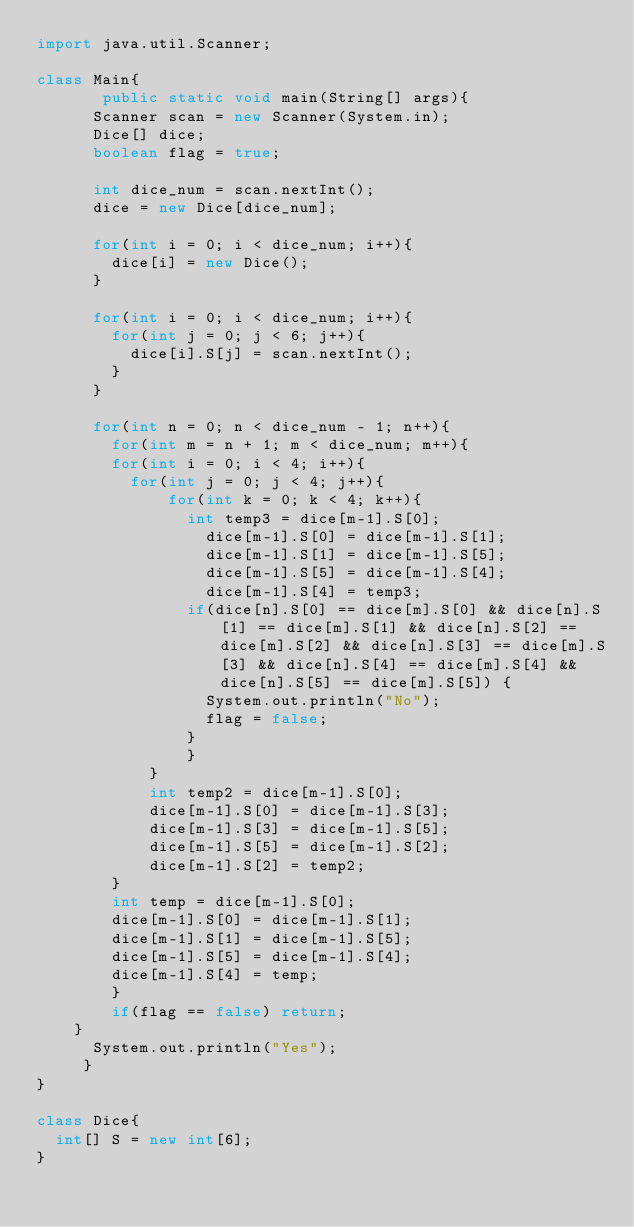<code> <loc_0><loc_0><loc_500><loc_500><_Java_>import java.util.Scanner;

class Main{
       public static void main(String[] args){
    	Scanner scan = new Scanner(System.in);
    	Dice[] dice;
    	boolean flag = true;
    	
    	int dice_num = scan.nextInt();
    	dice = new Dice[dice_num];
    	
    	for(int i = 0; i < dice_num; i++){
    		dice[i] = new Dice();
    	}
    	
    	for(int i = 0; i < dice_num; i++){
    		for(int j = 0; j < 6; j++){
    			dice[i].S[j] = scan.nextInt();
    		}
    	}
    	
    	for(int n = 0; n < dice_num - 1; n++){
    		for(int m = n + 1; m < dice_num; m++){
				for(int i = 0; i < 4; i++){
					for(int j = 0; j < 4; j++){
			    		for(int k = 0; k < 4; k++){
			    			int temp3 = dice[m-1].S[0];
			        		dice[m-1].S[0] = dice[m-1].S[1];
			        		dice[m-1].S[1] = dice[m-1].S[5];
			        		dice[m-1].S[5] = dice[m-1].S[4];
			        		dice[m-1].S[4] = temp3;
	    					if(dice[n].S[0] == dice[m].S[0] && dice[n].S[1] == dice[m].S[1] && dice[n].S[2] == dice[m].S[2] && dice[n].S[3] == dice[m].S[3] && dice[n].S[4] == dice[m].S[4] && dice[n].S[5] == dice[m].S[5]) {
	    						System.out.println("No");
	    						flag = false;
	    					}
			        	}
		    		}
		    		int temp2 = dice[m-1].S[0];
		    		dice[m-1].S[0] = dice[m-1].S[3];
		    		dice[m-1].S[3] = dice[m-1].S[5];
		    		dice[m-1].S[5] = dice[m-1].S[2];
		    		dice[m-1].S[2] = temp2;
				}
				int temp = dice[m-1].S[0];
				dice[m-1].S[0] = dice[m-1].S[1];
				dice[m-1].S[1] = dice[m-1].S[5];
				dice[m-1].S[5] = dice[m-1].S[4];
				dice[m-1].S[4] = temp;
    		}
    		if(flag == false) return;
		}
    	System.out.println("Yes");
     }
}

class Dice{
	int[] S = new int[6];
}</code> 